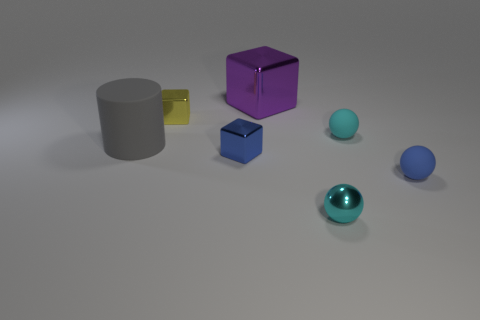Subtract all brown blocks. Subtract all yellow spheres. How many blocks are left? 3 Subtract all red balls. How many red cylinders are left? 0 Add 2 cyans. How many yellows exist? 0 Subtract all small red matte objects. Subtract all small blue blocks. How many objects are left? 6 Add 7 yellow metal cubes. How many yellow metal cubes are left? 8 Add 7 big yellow rubber cylinders. How many big yellow rubber cylinders exist? 7 Add 3 tiny blue shiny things. How many objects exist? 10 Subtract all cyan spheres. How many spheres are left? 1 Subtract all tiny shiny balls. How many balls are left? 2 Subtract 0 gray blocks. How many objects are left? 7 